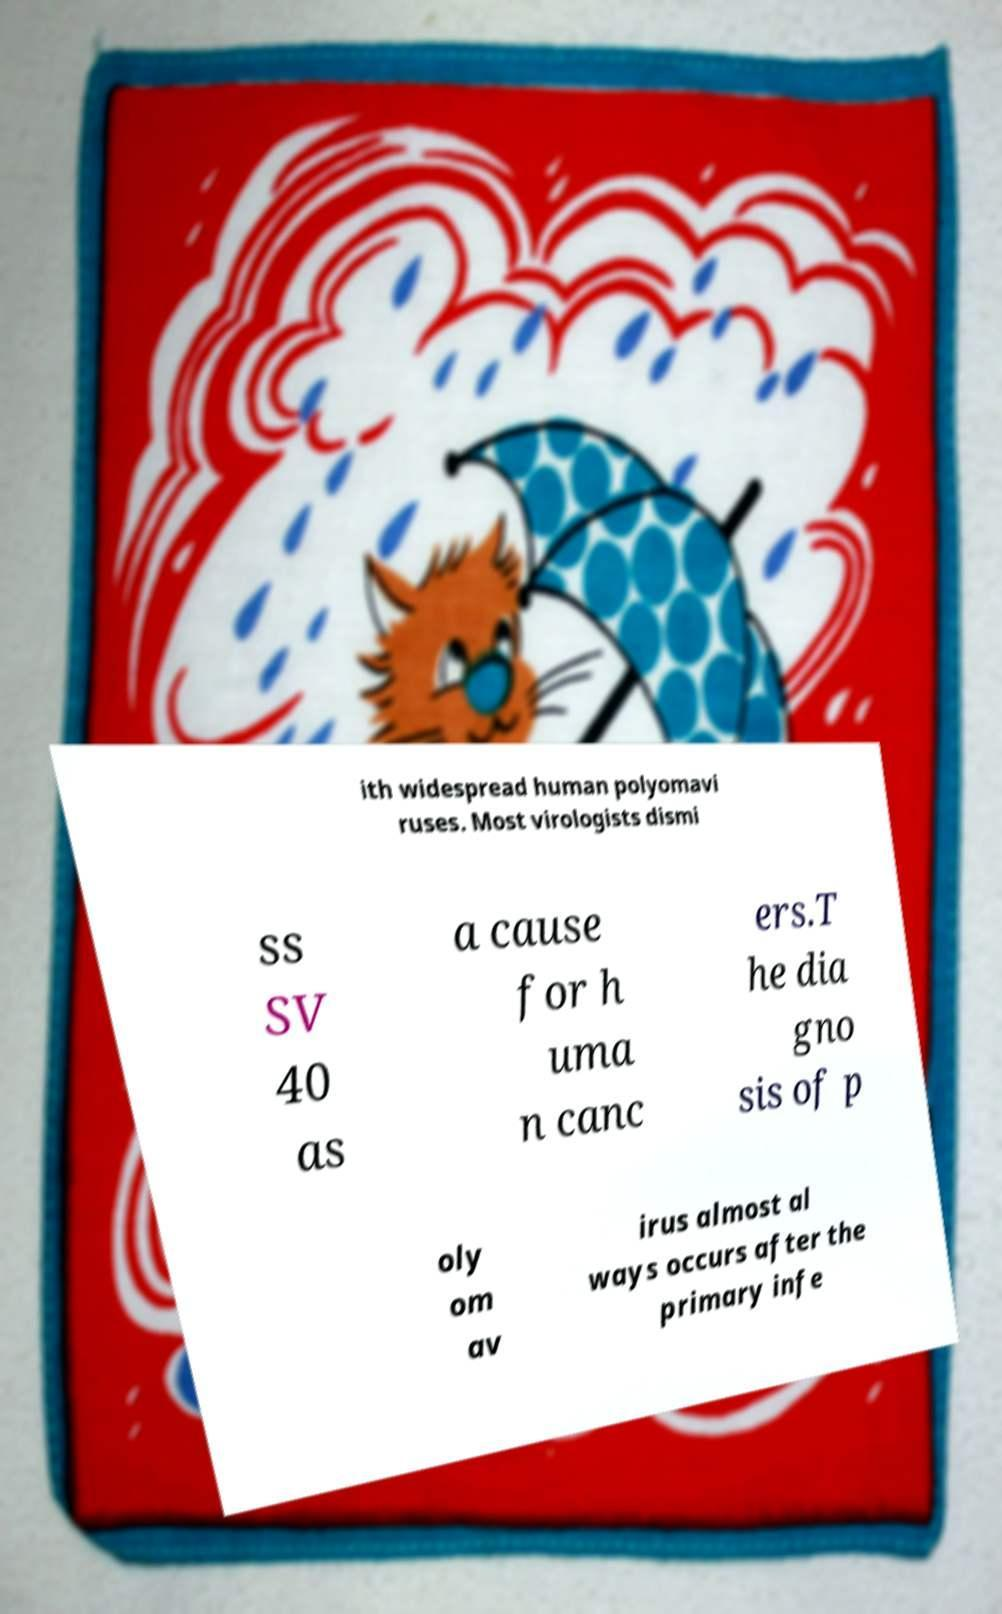Can you accurately transcribe the text from the provided image for me? ith widespread human polyomavi ruses. Most virologists dismi ss SV 40 as a cause for h uma n canc ers.T he dia gno sis of p oly om av irus almost al ways occurs after the primary infe 